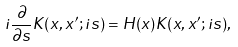<formula> <loc_0><loc_0><loc_500><loc_500>i \frac { \partial } { \partial s } K ( x , x ^ { \prime } ; i s ) = H ( x ) K ( x , x ^ { \prime } ; i s ) ,</formula> 